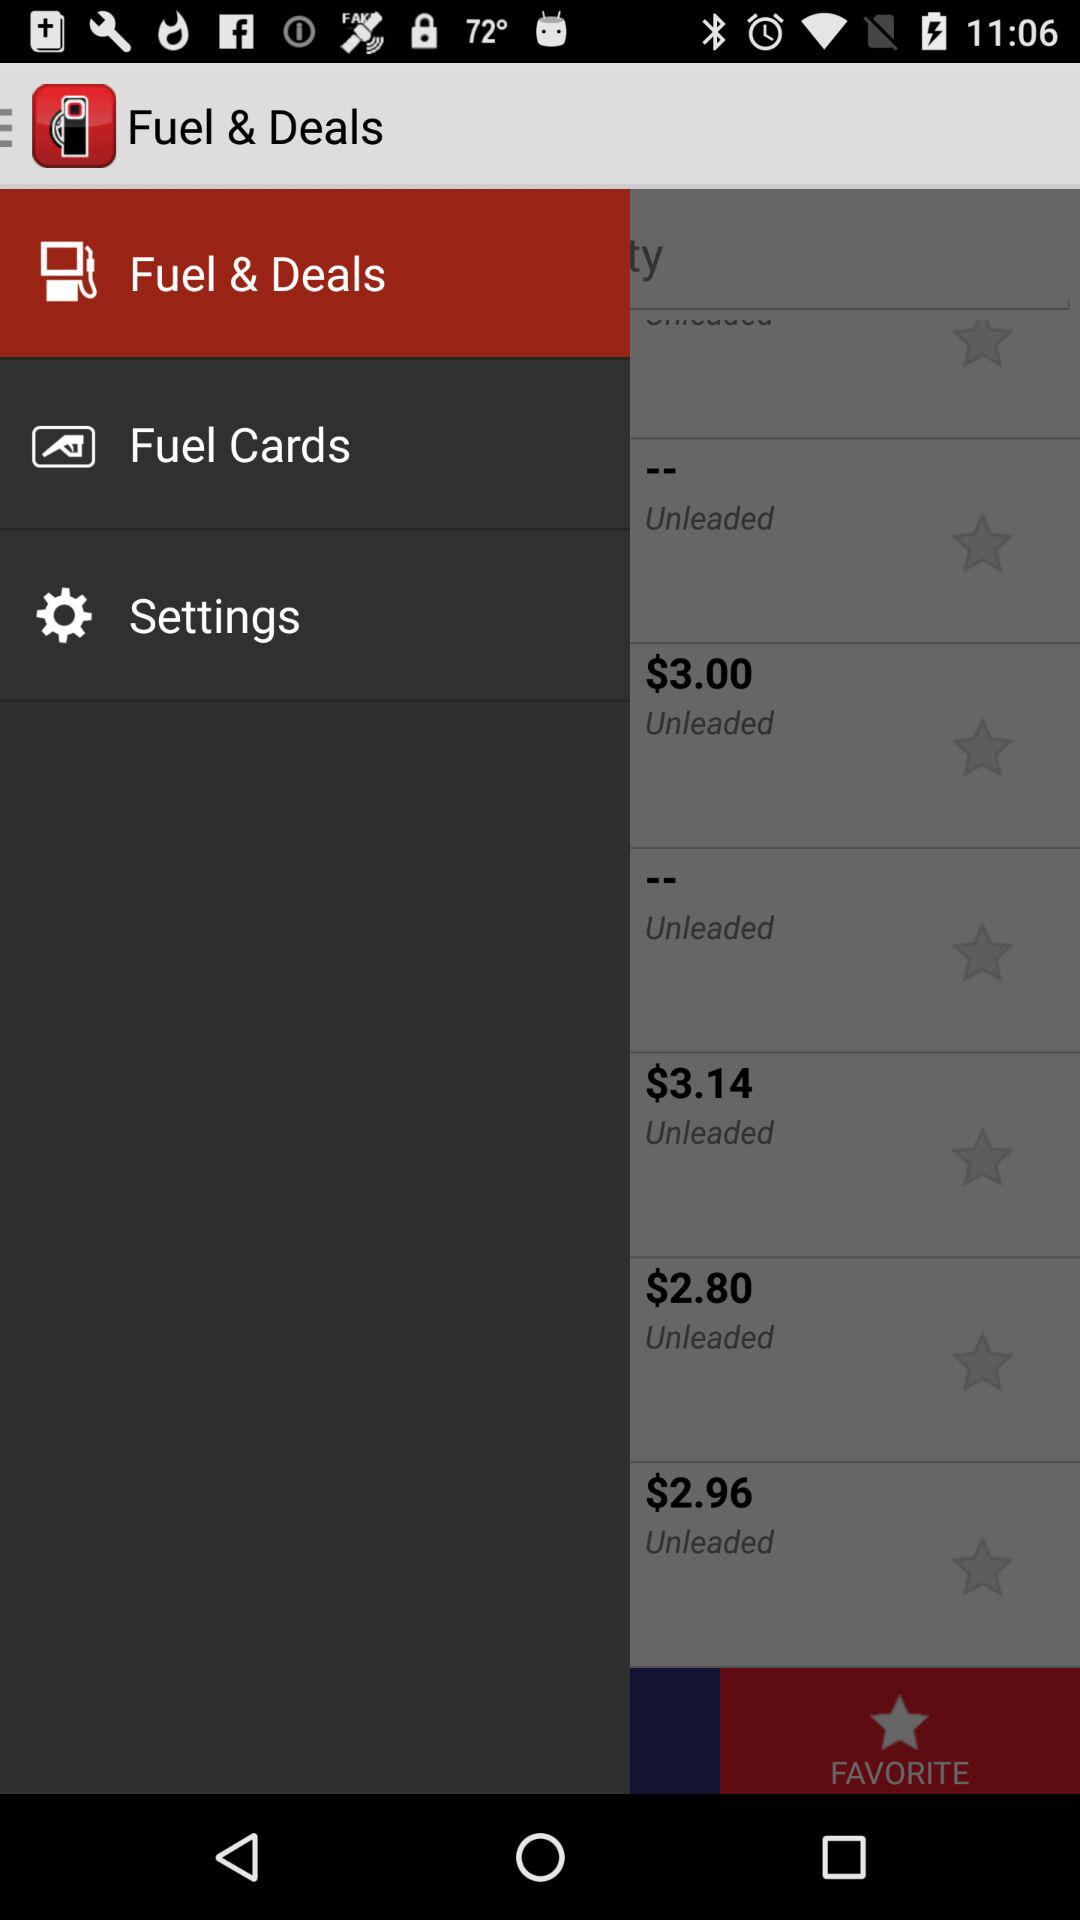How many unleaded gas options are there?
Answer the question using a single word or phrase. 6 